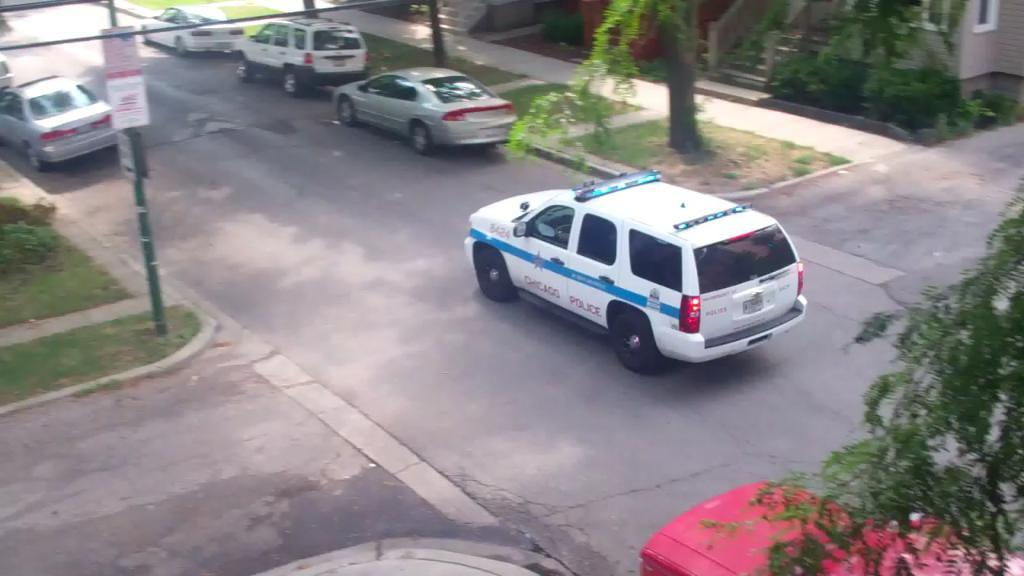What types of objects can be seen in the image? There are vehicles and poles in the image. What can be observed about the trees in the image? The trees in the image have green color. What is visible in the background of the image? There are buildings in the background of the image. Who is the creator of the meeting depicted in the image? There is no meeting depicted in the image, so it is not possible to determine who the creator might be. 